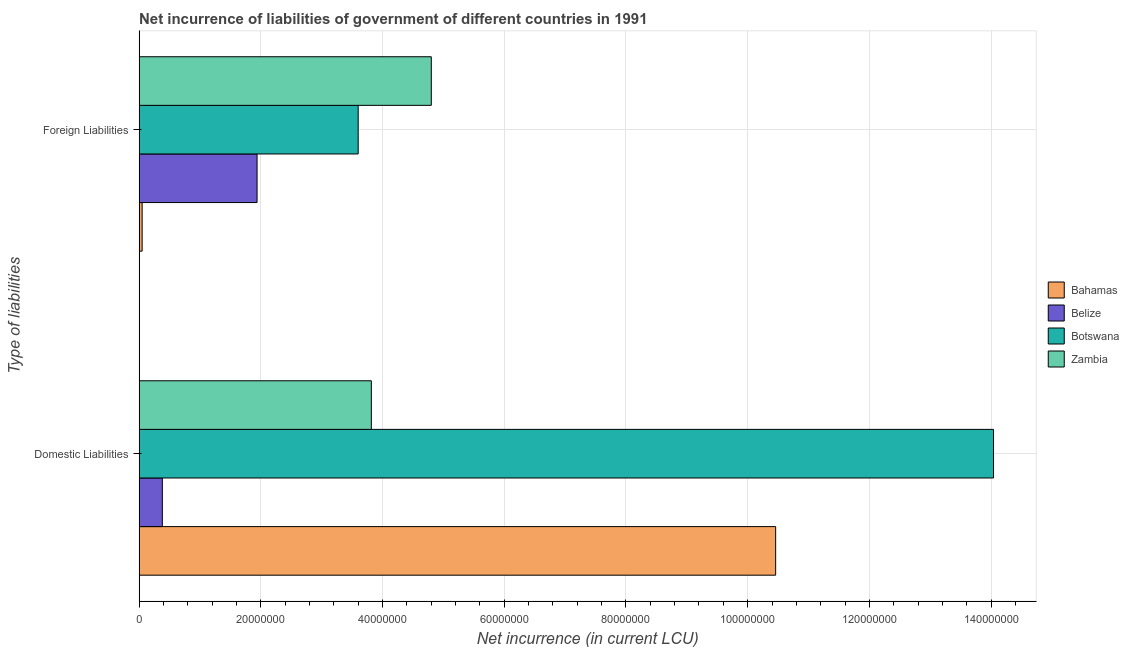How many groups of bars are there?
Provide a succinct answer. 2. How many bars are there on the 2nd tick from the bottom?
Make the answer very short. 4. What is the label of the 2nd group of bars from the top?
Make the answer very short. Domestic Liabilities. What is the net incurrence of domestic liabilities in Zambia?
Provide a succinct answer. 3.82e+07. Across all countries, what is the maximum net incurrence of domestic liabilities?
Give a very brief answer. 1.40e+08. Across all countries, what is the minimum net incurrence of foreign liabilities?
Make the answer very short. 5.00e+05. In which country was the net incurrence of foreign liabilities maximum?
Your answer should be compact. Zambia. In which country was the net incurrence of foreign liabilities minimum?
Keep it short and to the point. Bahamas. What is the total net incurrence of foreign liabilities in the graph?
Provide a succinct answer. 1.04e+08. What is the difference between the net incurrence of domestic liabilities in Botswana and that in Bahamas?
Keep it short and to the point. 3.58e+07. What is the difference between the net incurrence of domestic liabilities in Zambia and the net incurrence of foreign liabilities in Botswana?
Offer a terse response. 2.16e+06. What is the average net incurrence of foreign liabilities per country?
Your answer should be very brief. 2.60e+07. What is the difference between the net incurrence of foreign liabilities and net incurrence of domestic liabilities in Belize?
Your response must be concise. 1.56e+07. What is the ratio of the net incurrence of foreign liabilities in Bahamas to that in Botswana?
Make the answer very short. 0.01. Is the net incurrence of foreign liabilities in Belize less than that in Botswana?
Your answer should be compact. Yes. What does the 2nd bar from the top in Foreign Liabilities represents?
Keep it short and to the point. Botswana. What does the 3rd bar from the bottom in Foreign Liabilities represents?
Ensure brevity in your answer.  Botswana. How many bars are there?
Keep it short and to the point. 8. Are all the bars in the graph horizontal?
Provide a succinct answer. Yes. Does the graph contain grids?
Your answer should be compact. Yes. How are the legend labels stacked?
Your response must be concise. Vertical. What is the title of the graph?
Make the answer very short. Net incurrence of liabilities of government of different countries in 1991. Does "Mongolia" appear as one of the legend labels in the graph?
Provide a succinct answer. No. What is the label or title of the X-axis?
Offer a terse response. Net incurrence (in current LCU). What is the label or title of the Y-axis?
Your answer should be compact. Type of liabilities. What is the Net incurrence (in current LCU) in Bahamas in Domestic Liabilities?
Provide a short and direct response. 1.05e+08. What is the Net incurrence (in current LCU) in Belize in Domestic Liabilities?
Provide a short and direct response. 3.82e+06. What is the Net incurrence (in current LCU) of Botswana in Domestic Liabilities?
Make the answer very short. 1.40e+08. What is the Net incurrence (in current LCU) in Zambia in Domestic Liabilities?
Offer a terse response. 3.82e+07. What is the Net incurrence (in current LCU) of Bahamas in Foreign Liabilities?
Your answer should be very brief. 5.00e+05. What is the Net incurrence (in current LCU) in Belize in Foreign Liabilities?
Ensure brevity in your answer.  1.94e+07. What is the Net incurrence (in current LCU) of Botswana in Foreign Liabilities?
Offer a very short reply. 3.60e+07. What is the Net incurrence (in current LCU) in Zambia in Foreign Liabilities?
Give a very brief answer. 4.80e+07. Across all Type of liabilities, what is the maximum Net incurrence (in current LCU) of Bahamas?
Give a very brief answer. 1.05e+08. Across all Type of liabilities, what is the maximum Net incurrence (in current LCU) in Belize?
Your answer should be compact. 1.94e+07. Across all Type of liabilities, what is the maximum Net incurrence (in current LCU) of Botswana?
Your response must be concise. 1.40e+08. Across all Type of liabilities, what is the maximum Net incurrence (in current LCU) of Zambia?
Ensure brevity in your answer.  4.80e+07. Across all Type of liabilities, what is the minimum Net incurrence (in current LCU) in Bahamas?
Your answer should be compact. 5.00e+05. Across all Type of liabilities, what is the minimum Net incurrence (in current LCU) in Belize?
Make the answer very short. 3.82e+06. Across all Type of liabilities, what is the minimum Net incurrence (in current LCU) of Botswana?
Provide a short and direct response. 3.60e+07. Across all Type of liabilities, what is the minimum Net incurrence (in current LCU) of Zambia?
Offer a terse response. 3.82e+07. What is the total Net incurrence (in current LCU) of Bahamas in the graph?
Provide a short and direct response. 1.05e+08. What is the total Net incurrence (in current LCU) in Belize in the graph?
Your answer should be compact. 2.32e+07. What is the total Net incurrence (in current LCU) in Botswana in the graph?
Give a very brief answer. 1.76e+08. What is the total Net incurrence (in current LCU) in Zambia in the graph?
Keep it short and to the point. 8.62e+07. What is the difference between the Net incurrence (in current LCU) of Bahamas in Domestic Liabilities and that in Foreign Liabilities?
Provide a short and direct response. 1.04e+08. What is the difference between the Net incurrence (in current LCU) of Belize in Domestic Liabilities and that in Foreign Liabilities?
Ensure brevity in your answer.  -1.56e+07. What is the difference between the Net incurrence (in current LCU) of Botswana in Domestic Liabilities and that in Foreign Liabilities?
Your answer should be very brief. 1.04e+08. What is the difference between the Net incurrence (in current LCU) in Zambia in Domestic Liabilities and that in Foreign Liabilities?
Your response must be concise. -9.85e+06. What is the difference between the Net incurrence (in current LCU) of Bahamas in Domestic Liabilities and the Net incurrence (in current LCU) of Belize in Foreign Liabilities?
Your answer should be compact. 8.52e+07. What is the difference between the Net incurrence (in current LCU) in Bahamas in Domestic Liabilities and the Net incurrence (in current LCU) in Botswana in Foreign Liabilities?
Ensure brevity in your answer.  6.86e+07. What is the difference between the Net incurrence (in current LCU) in Bahamas in Domestic Liabilities and the Net incurrence (in current LCU) in Zambia in Foreign Liabilities?
Your response must be concise. 5.66e+07. What is the difference between the Net incurrence (in current LCU) in Belize in Domestic Liabilities and the Net incurrence (in current LCU) in Botswana in Foreign Liabilities?
Your answer should be very brief. -3.22e+07. What is the difference between the Net incurrence (in current LCU) of Belize in Domestic Liabilities and the Net incurrence (in current LCU) of Zambia in Foreign Liabilities?
Provide a short and direct response. -4.42e+07. What is the difference between the Net incurrence (in current LCU) in Botswana in Domestic Liabilities and the Net incurrence (in current LCU) in Zambia in Foreign Liabilities?
Provide a succinct answer. 9.24e+07. What is the average Net incurrence (in current LCU) in Bahamas per Type of liabilities?
Offer a very short reply. 5.26e+07. What is the average Net incurrence (in current LCU) in Belize per Type of liabilities?
Ensure brevity in your answer.  1.16e+07. What is the average Net incurrence (in current LCU) in Botswana per Type of liabilities?
Offer a terse response. 8.82e+07. What is the average Net incurrence (in current LCU) in Zambia per Type of liabilities?
Your answer should be compact. 4.31e+07. What is the difference between the Net incurrence (in current LCU) of Bahamas and Net incurrence (in current LCU) of Belize in Domestic Liabilities?
Your answer should be very brief. 1.01e+08. What is the difference between the Net incurrence (in current LCU) in Bahamas and Net incurrence (in current LCU) in Botswana in Domestic Liabilities?
Offer a very short reply. -3.58e+07. What is the difference between the Net incurrence (in current LCU) of Bahamas and Net incurrence (in current LCU) of Zambia in Domestic Liabilities?
Your answer should be compact. 6.64e+07. What is the difference between the Net incurrence (in current LCU) in Belize and Net incurrence (in current LCU) in Botswana in Domestic Liabilities?
Your response must be concise. -1.37e+08. What is the difference between the Net incurrence (in current LCU) in Belize and Net incurrence (in current LCU) in Zambia in Domestic Liabilities?
Give a very brief answer. -3.43e+07. What is the difference between the Net incurrence (in current LCU) in Botswana and Net incurrence (in current LCU) in Zambia in Domestic Liabilities?
Keep it short and to the point. 1.02e+08. What is the difference between the Net incurrence (in current LCU) of Bahamas and Net incurrence (in current LCU) of Belize in Foreign Liabilities?
Provide a short and direct response. -1.89e+07. What is the difference between the Net incurrence (in current LCU) of Bahamas and Net incurrence (in current LCU) of Botswana in Foreign Liabilities?
Make the answer very short. -3.55e+07. What is the difference between the Net incurrence (in current LCU) in Bahamas and Net incurrence (in current LCU) in Zambia in Foreign Liabilities?
Keep it short and to the point. -4.75e+07. What is the difference between the Net incurrence (in current LCU) of Belize and Net incurrence (in current LCU) of Botswana in Foreign Liabilities?
Keep it short and to the point. -1.66e+07. What is the difference between the Net incurrence (in current LCU) of Belize and Net incurrence (in current LCU) of Zambia in Foreign Liabilities?
Your answer should be very brief. -2.86e+07. What is the difference between the Net incurrence (in current LCU) in Botswana and Net incurrence (in current LCU) in Zambia in Foreign Liabilities?
Offer a very short reply. -1.20e+07. What is the ratio of the Net incurrence (in current LCU) of Bahamas in Domestic Liabilities to that in Foreign Liabilities?
Offer a terse response. 209.2. What is the ratio of the Net incurrence (in current LCU) of Belize in Domestic Liabilities to that in Foreign Liabilities?
Offer a very short reply. 0.2. What is the ratio of the Net incurrence (in current LCU) in Botswana in Domestic Liabilities to that in Foreign Liabilities?
Ensure brevity in your answer.  3.9. What is the ratio of the Net incurrence (in current LCU) of Zambia in Domestic Liabilities to that in Foreign Liabilities?
Your response must be concise. 0.79. What is the difference between the highest and the second highest Net incurrence (in current LCU) of Bahamas?
Make the answer very short. 1.04e+08. What is the difference between the highest and the second highest Net incurrence (in current LCU) of Belize?
Ensure brevity in your answer.  1.56e+07. What is the difference between the highest and the second highest Net incurrence (in current LCU) in Botswana?
Your answer should be compact. 1.04e+08. What is the difference between the highest and the second highest Net incurrence (in current LCU) in Zambia?
Ensure brevity in your answer.  9.85e+06. What is the difference between the highest and the lowest Net incurrence (in current LCU) of Bahamas?
Your answer should be compact. 1.04e+08. What is the difference between the highest and the lowest Net incurrence (in current LCU) in Belize?
Offer a very short reply. 1.56e+07. What is the difference between the highest and the lowest Net incurrence (in current LCU) of Botswana?
Keep it short and to the point. 1.04e+08. What is the difference between the highest and the lowest Net incurrence (in current LCU) in Zambia?
Provide a short and direct response. 9.85e+06. 